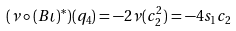Convert formula to latex. <formula><loc_0><loc_0><loc_500><loc_500>( \nu \circ ( B \iota ) ^ { \ast } ) ( q _ { 4 } ) = - 2 \nu ( c _ { 2 } ^ { 2 } ) = - 4 s _ { 1 } c _ { 2 }</formula> 